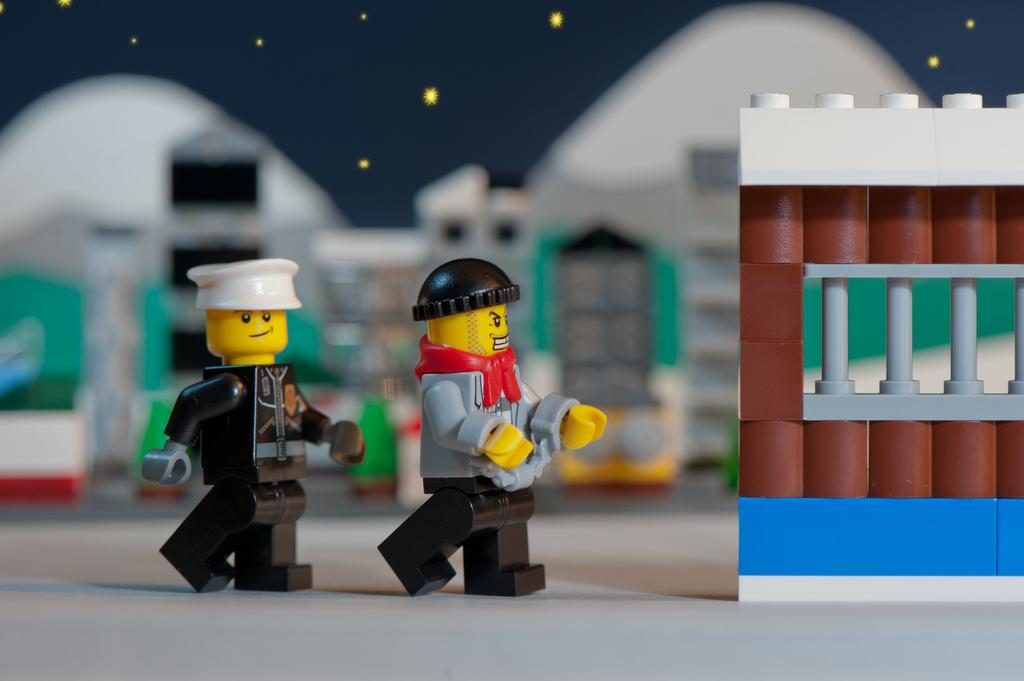What objects are on the table in the image? There are toys and blocks on the table in the image. Can you describe the toys on the table? The toys on the table are not specified, but they are present along with the blocks. What type of hook can be seen hanging from the ceiling in the image? There is no hook present in the image; it only features toys and blocks on the table. 